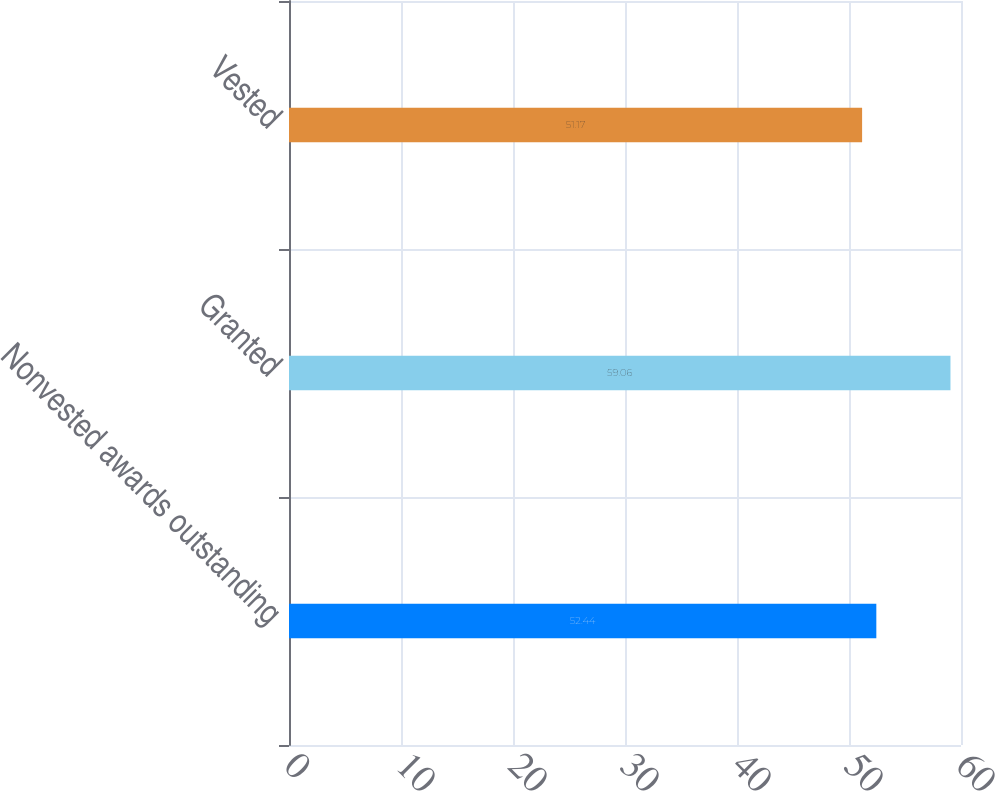<chart> <loc_0><loc_0><loc_500><loc_500><bar_chart><fcel>Nonvested awards outstanding<fcel>Granted<fcel>Vested<nl><fcel>52.44<fcel>59.06<fcel>51.17<nl></chart> 